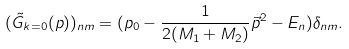<formula> <loc_0><loc_0><loc_500><loc_500>( \tilde { G } _ { k = 0 } ( p ) ) _ { n m } = ( p _ { 0 } - \frac { 1 } { 2 ( M _ { 1 } + M _ { 2 } ) } \vec { p } ^ { 2 } - E _ { n } ) \delta _ { n m } .</formula> 